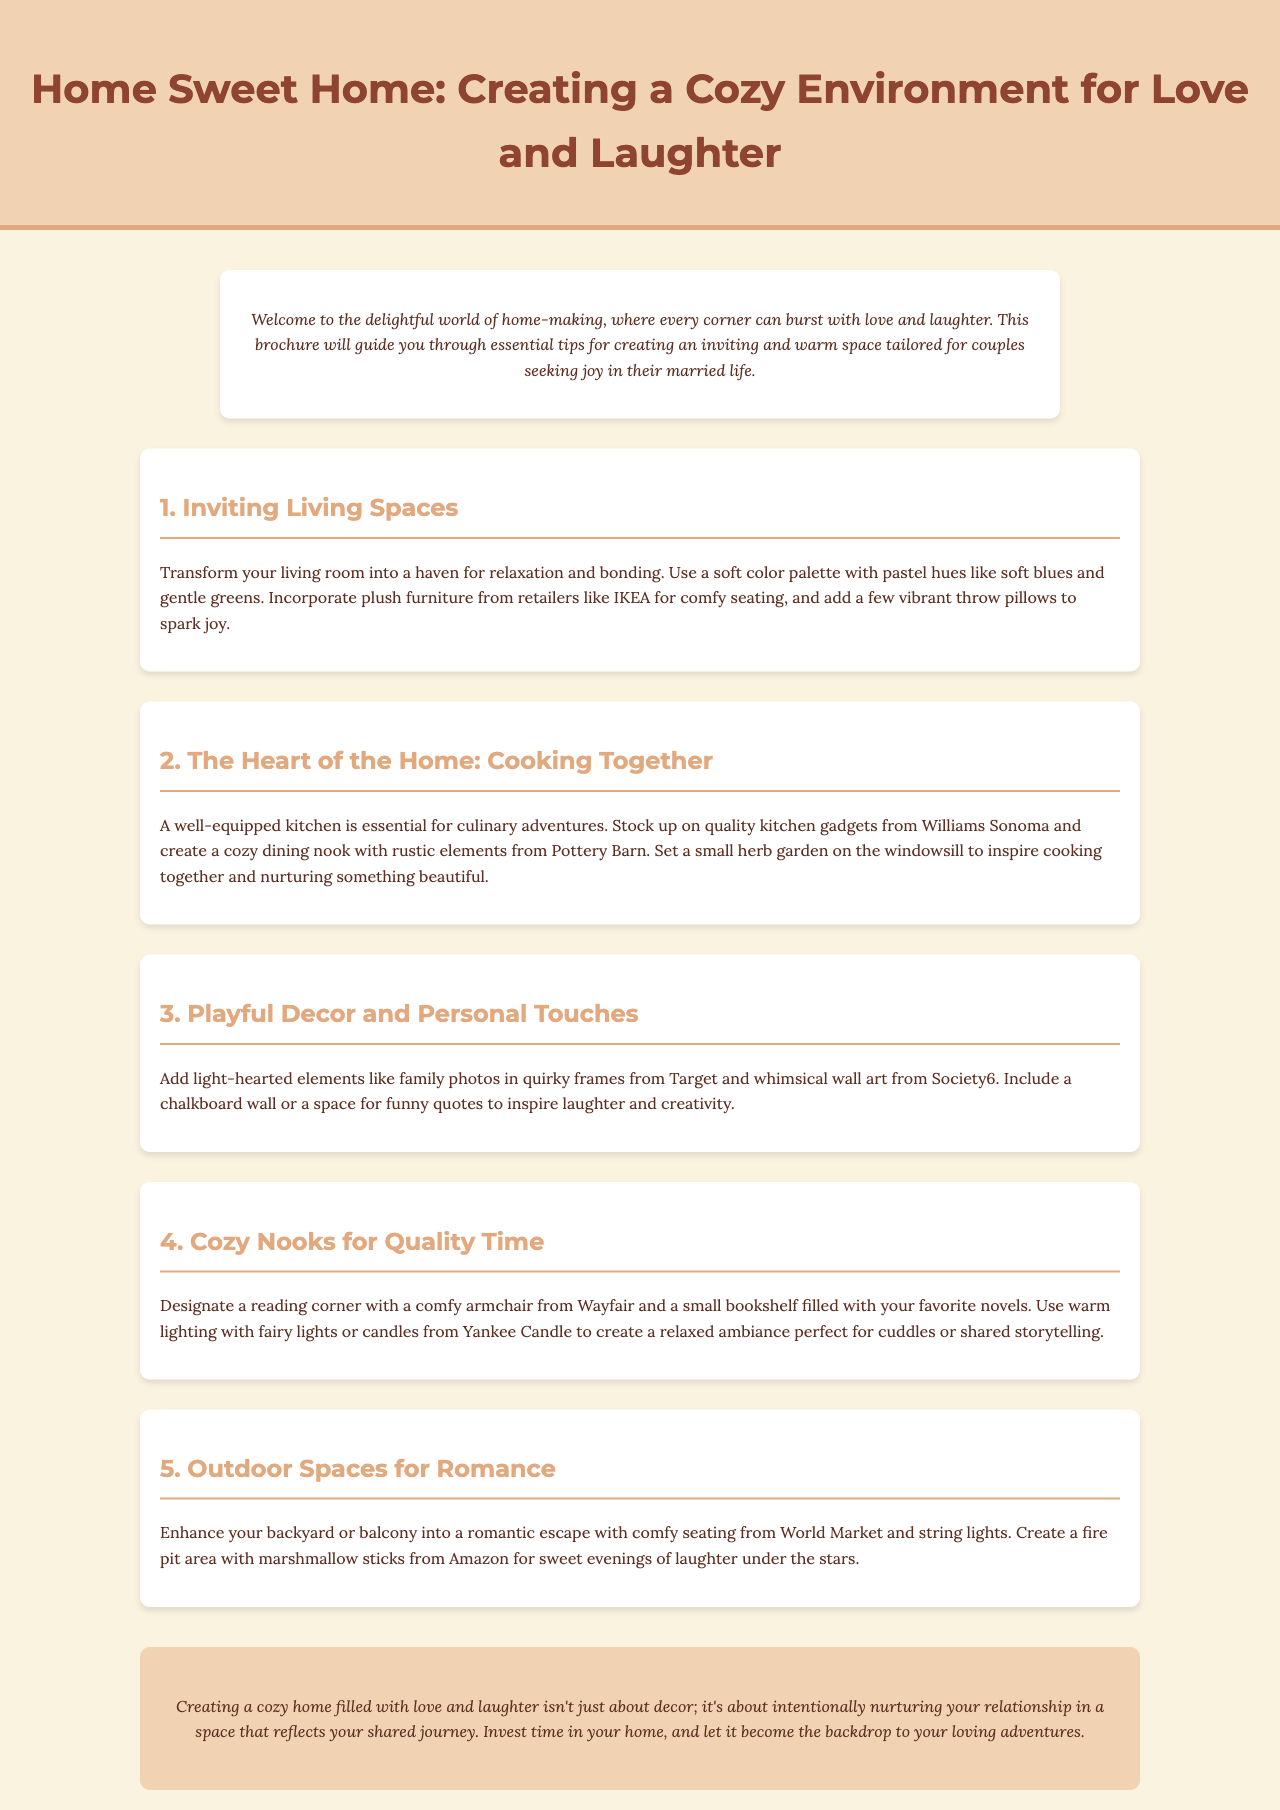What is the title of the brochure? The title of the brochure is presented prominently in the header section.
Answer: Home Sweet Home: Creating a Cozy Environment for Love and Laughter What is the first section about? The first section describes how to make the living room inviting and cozy.
Answer: Inviting Living Spaces What color palette is suggested for the living room? The document specifies a soft color palette with pastel hues.
Answer: Soft blues and gentle greens Which retailer is mentioned for plush furniture? The brochure references a specific retailer for furnishing solutions.
Answer: IKEA What kitchen items should be stocked up according to the document? The second section mentions essential items for culinary adventures.
Answer: Quality kitchen gadgets What decorative item is suggested for adding a playful touch? The document lists specific items to enhance home decor.
Answer: Quirky frames How should the reading corner be lit? The brochure suggests various lighting options for creating ambiance.
Answer: Warm lighting with fairy lights or candles What outdoor element is recommended for creating romance? The document suggests an item to enhance outdoor spaces.
Answer: String lights What is highlighted as essential for a cozy home environment? The conclusion emphasizes a key aspect for enriching the home space.
Answer: Intentionally nurturing your relationship 